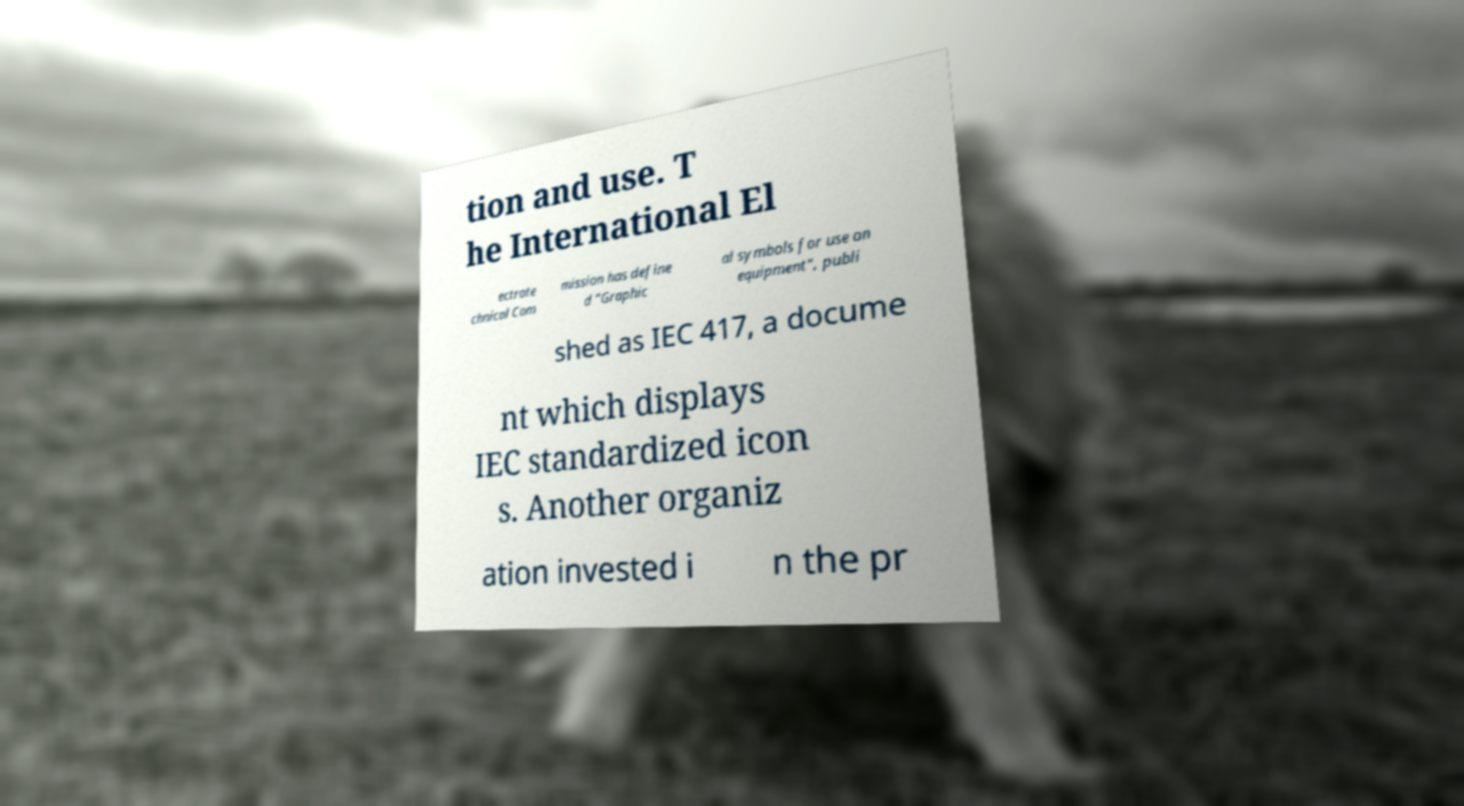I need the written content from this picture converted into text. Can you do that? tion and use. T he International El ectrote chnical Com mission has define d "Graphic al symbols for use on equipment", publi shed as IEC 417, a docume nt which displays IEC standardized icon s. Another organiz ation invested i n the pr 